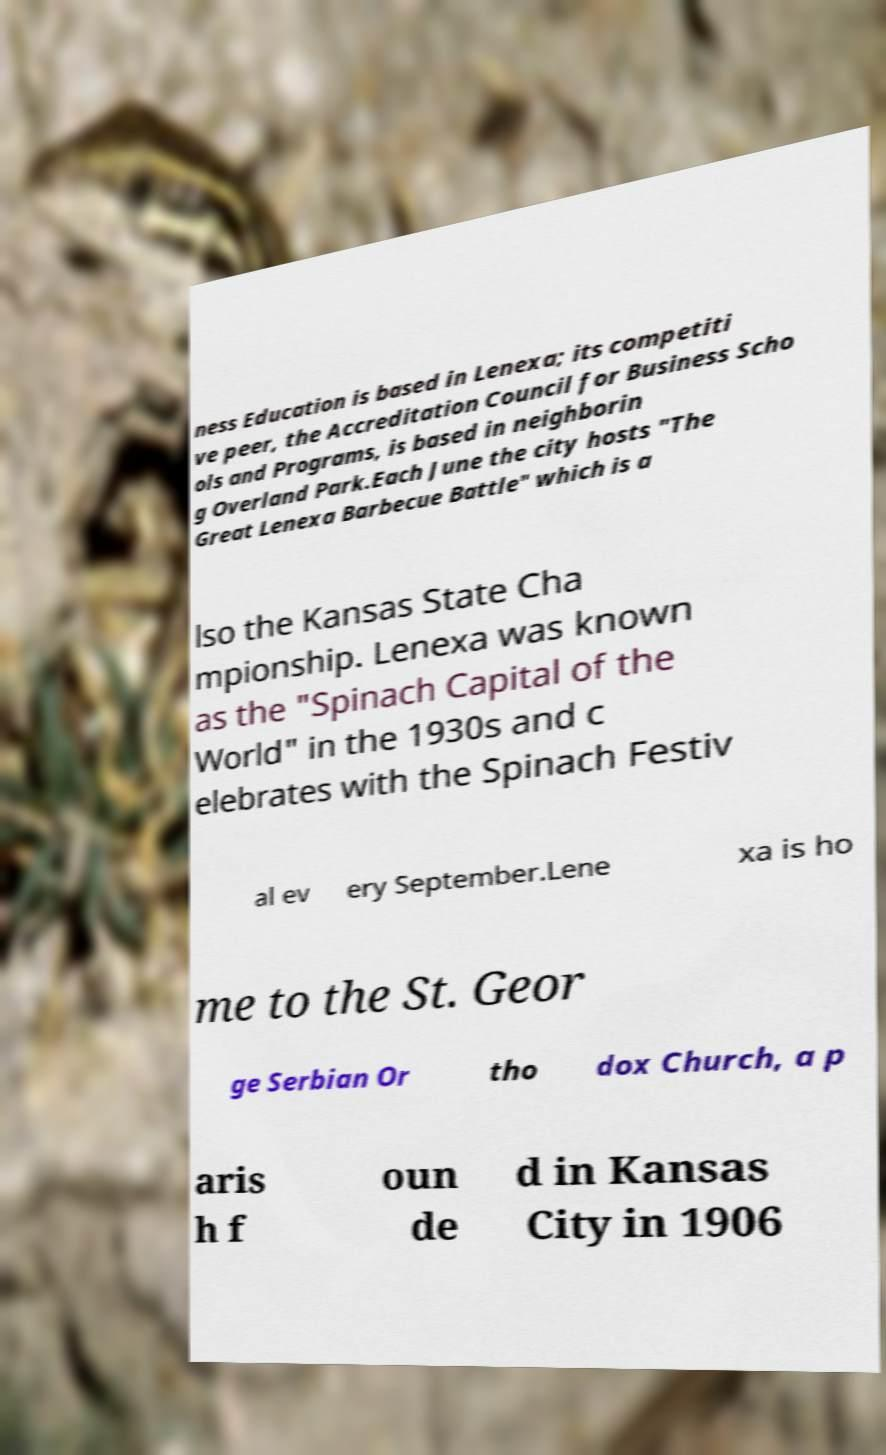What messages or text are displayed in this image? I need them in a readable, typed format. ness Education is based in Lenexa; its competiti ve peer, the Accreditation Council for Business Scho ols and Programs, is based in neighborin g Overland Park.Each June the city hosts "The Great Lenexa Barbecue Battle" which is a lso the Kansas State Cha mpionship. Lenexa was known as the "Spinach Capital of the World" in the 1930s and c elebrates with the Spinach Festiv al ev ery September.Lene xa is ho me to the St. Geor ge Serbian Or tho dox Church, a p aris h f oun de d in Kansas City in 1906 